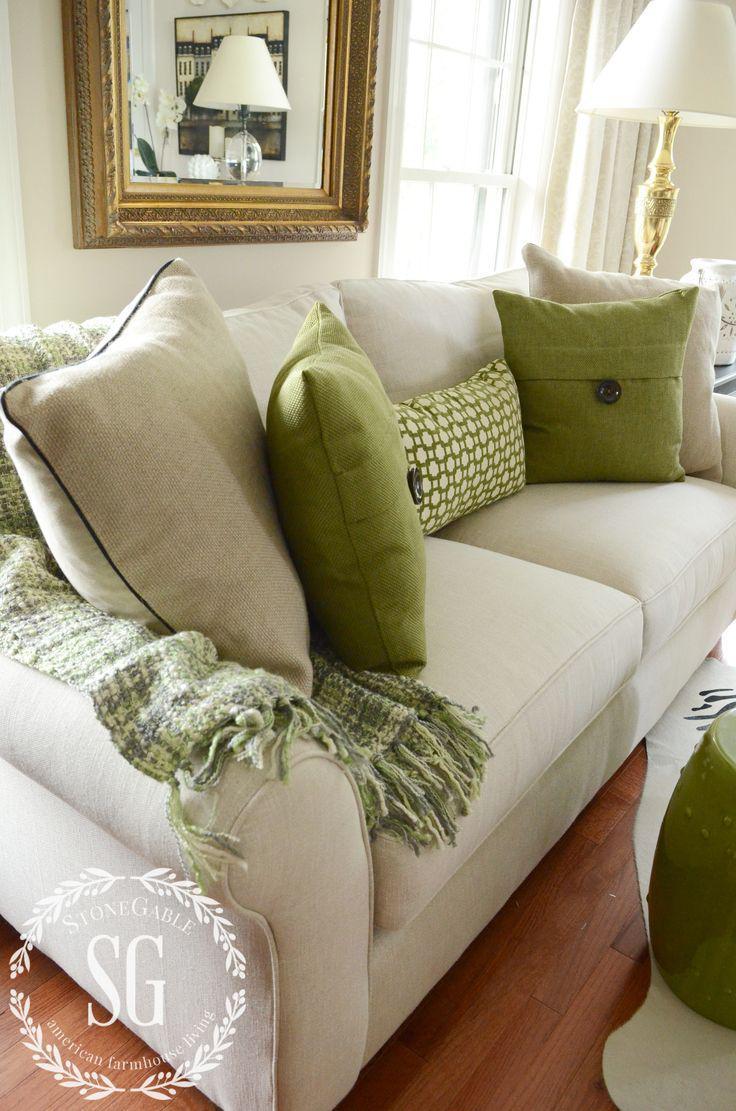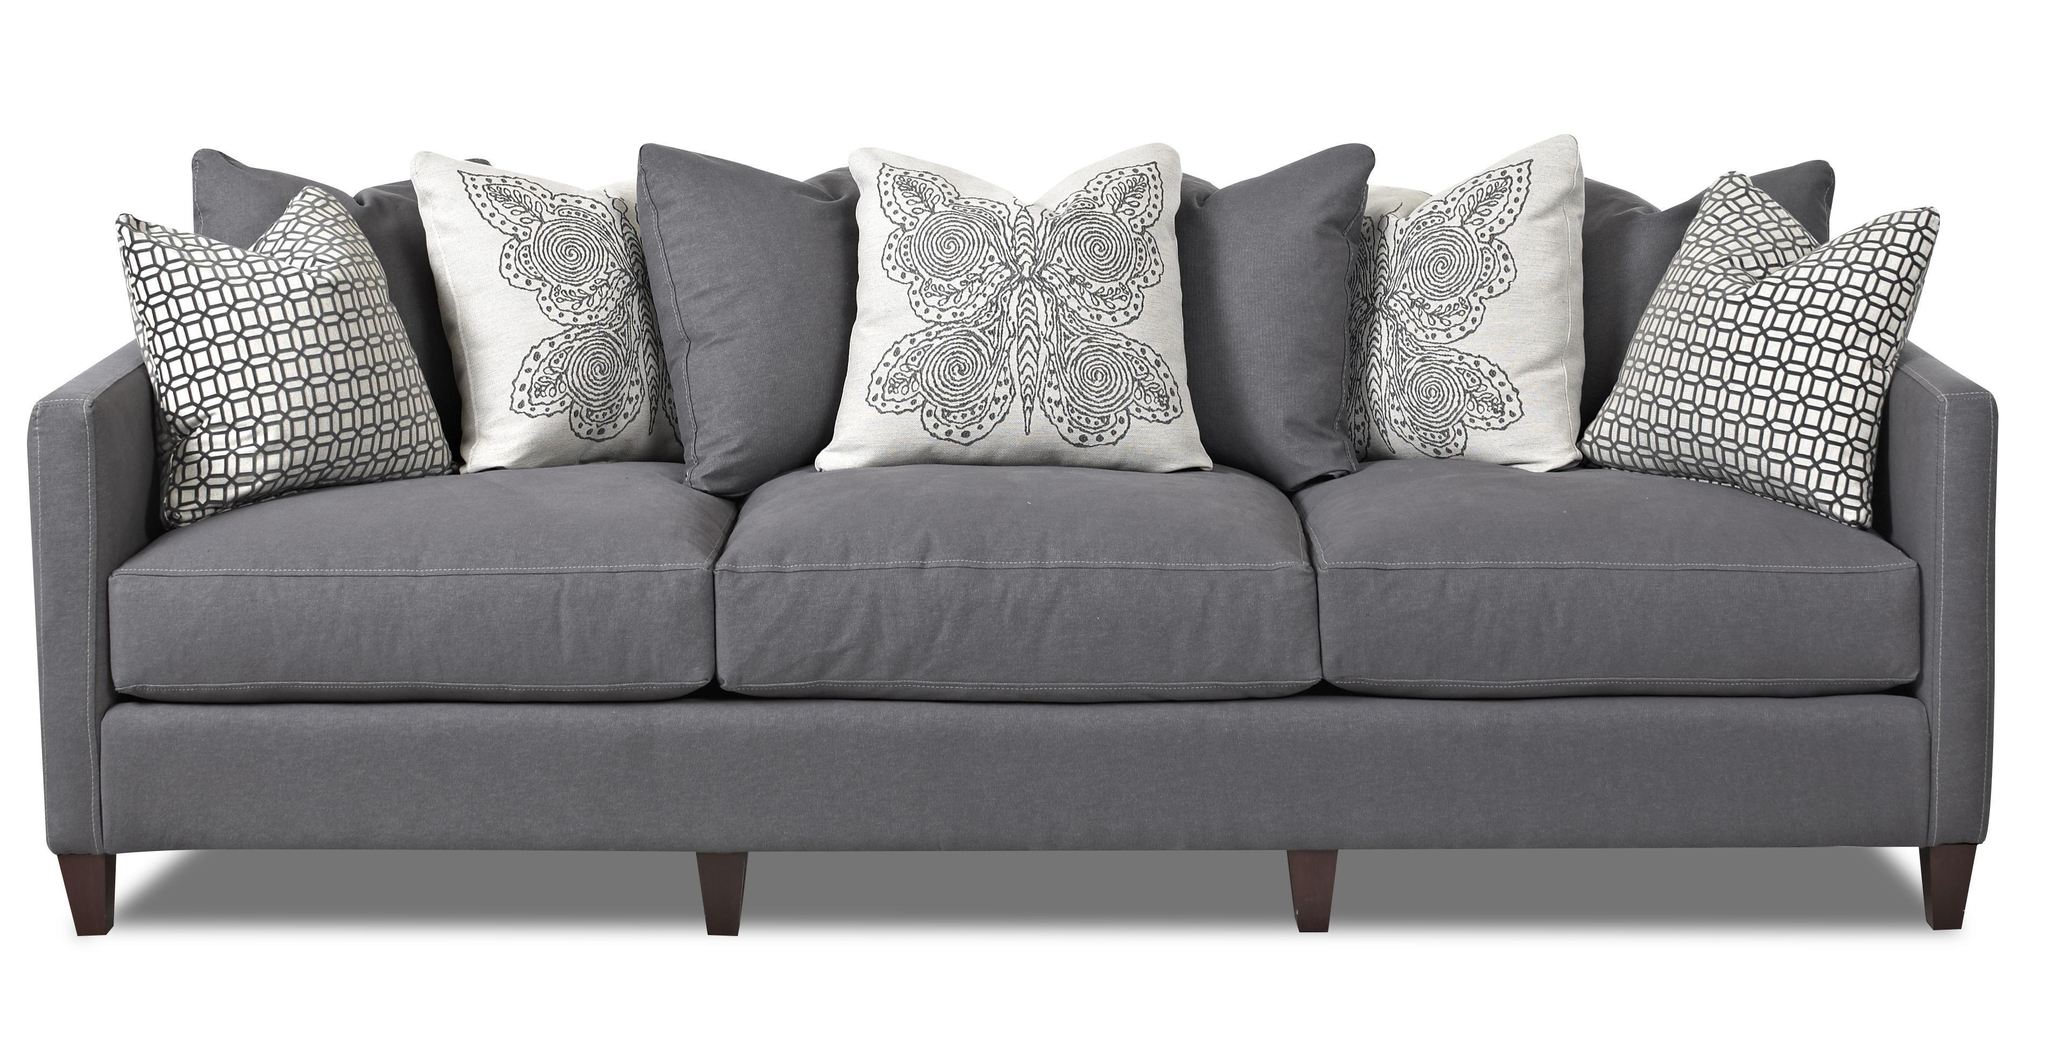The first image is the image on the left, the second image is the image on the right. Assess this claim about the two images: "There are two throw pillows with different color circle patterns sitting on top of a sofa.". Correct or not? Answer yes or no. No. The first image is the image on the left, the second image is the image on the right. Assess this claim about the two images: "Each image features one diagonally-displayed three-cushion footed couch, with two matching patterned pillows positioned one on each end of the couch.". Correct or not? Answer yes or no. No. 